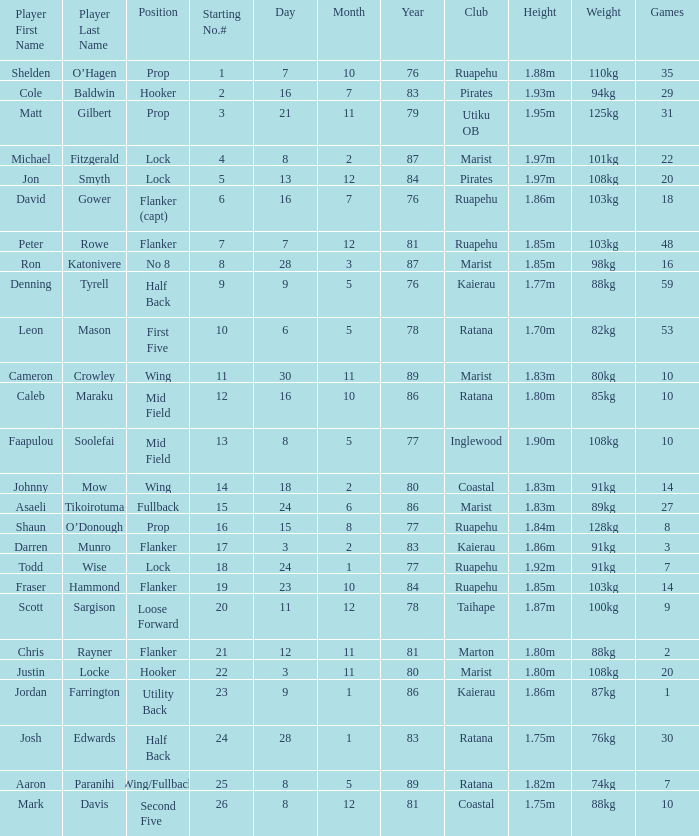How many games were played where the player's height is 1.0. 